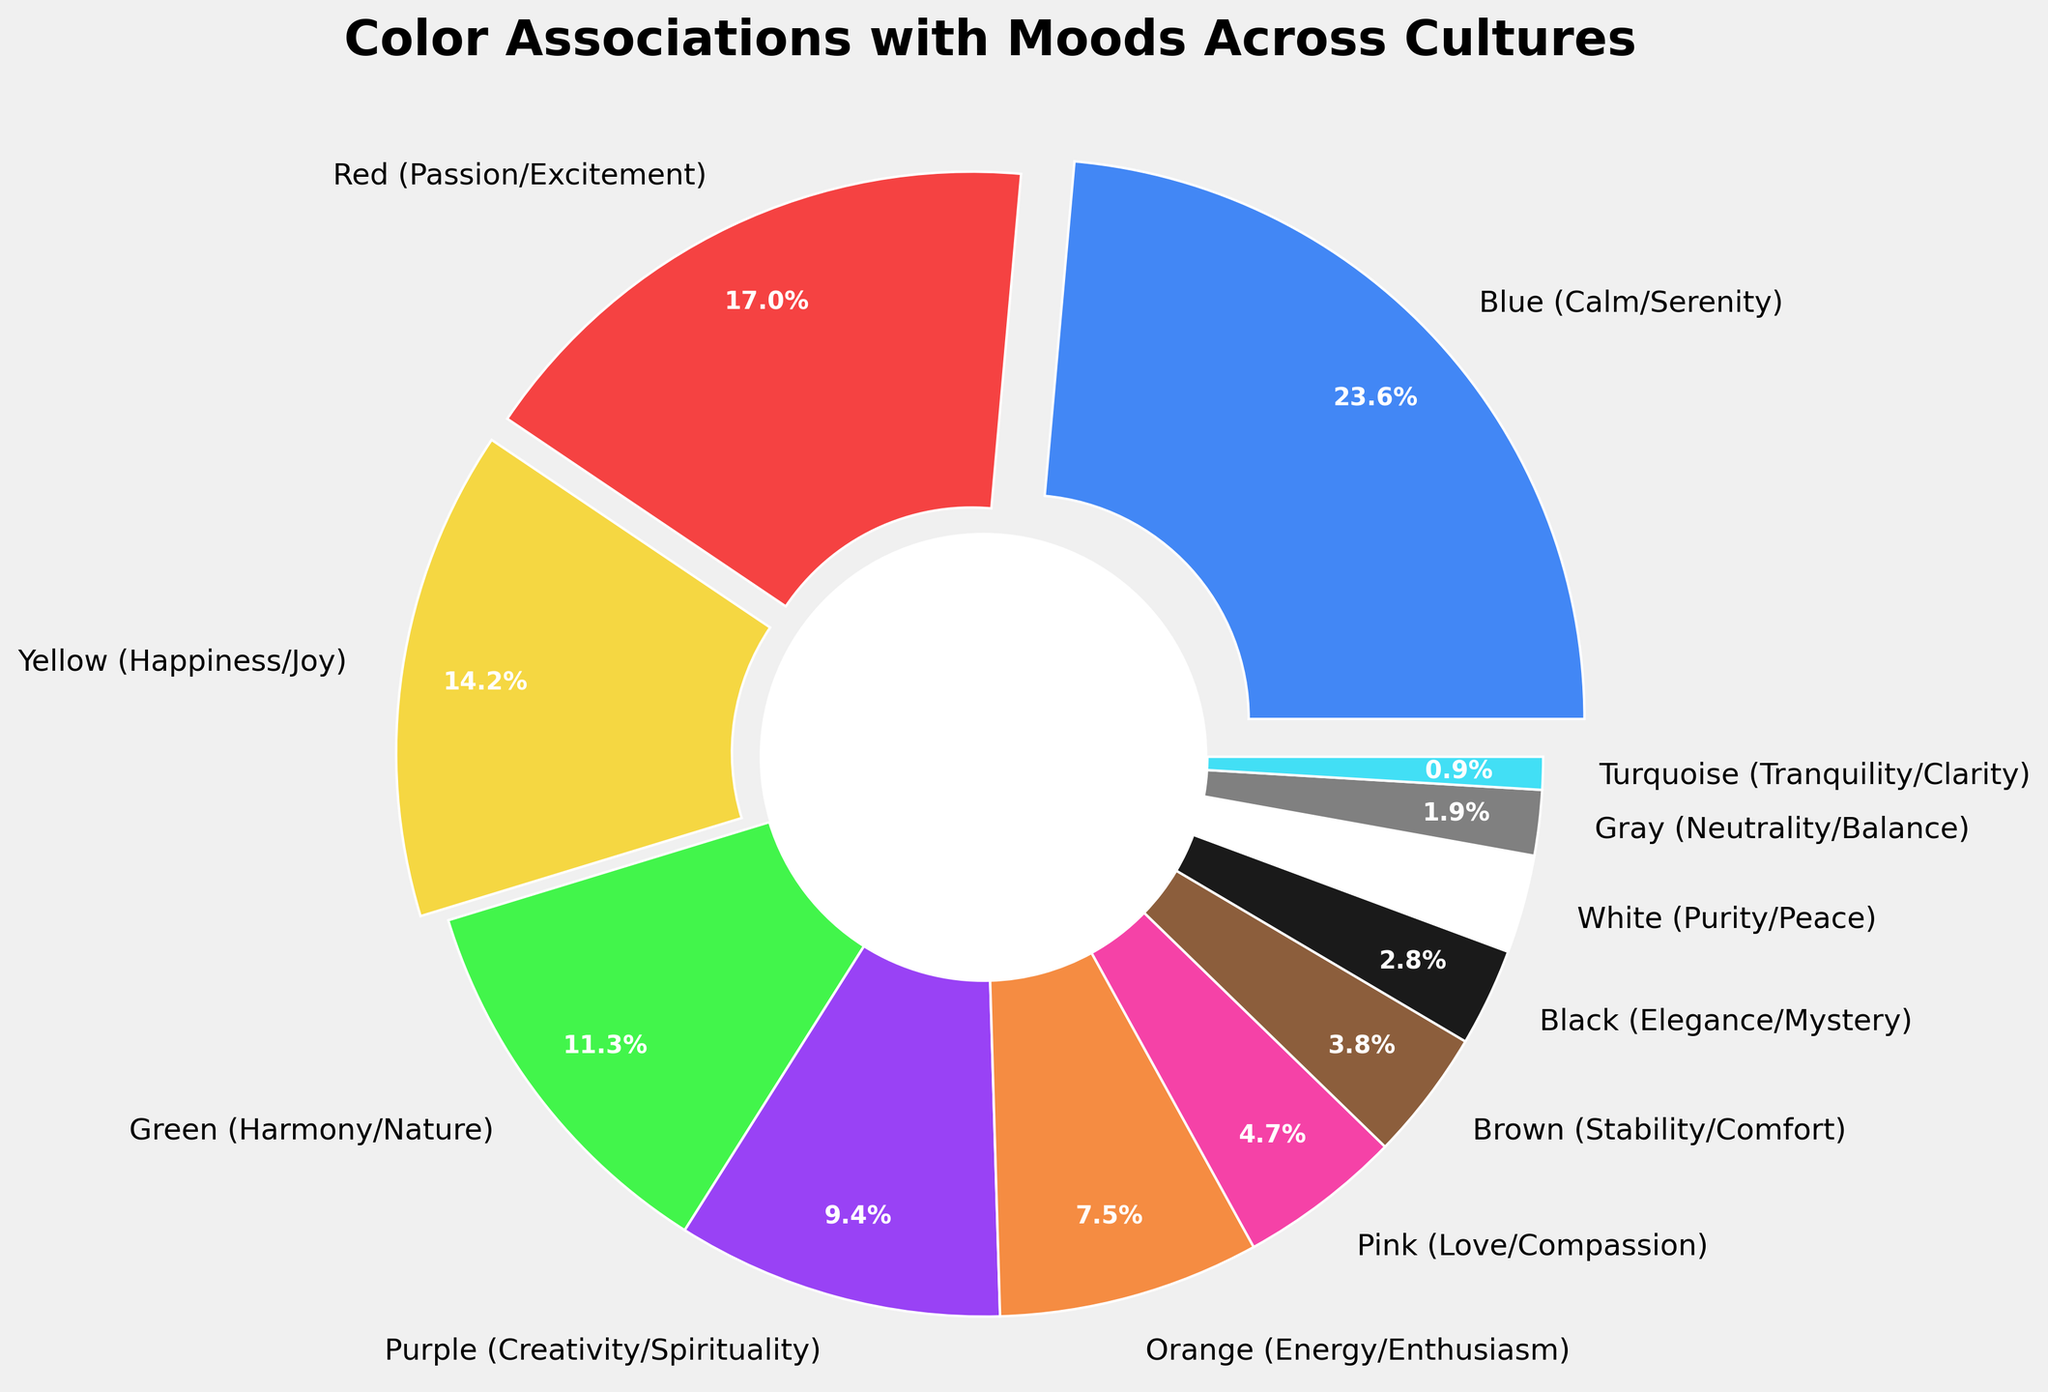Which color is most commonly associated with calm or serenity? By examining the pie chart, the segment with the label "Blue (Calm/Serenity)" is the largest, indicating it has the highest percentage.
Answer: Blue Which mood is least associated with a color according to the pie chart? The smallest segment in the pie chart corresponds to the label "Turquoise (Tranquility/Clarity)", indicating it has the lowest percentage.
Answer: Tranquility/Clarity What is the total percentage of colors associated with positive moods (Calm/Serenity, Happiness/Joy, Energy/Enthusiasm, Love/Compassion)? Adding the percentages of Blue (25), Yellow (15), Orange (8), and Pink (5) gives us 25 + 15 + 8 + 5 = 53%.
Answer: 53% How does the percentage of colors associated with Passion/Excitement compare to those associated with Harmony/Nature? By comparing the segments for Red (18) and Green (12), we can see that the segment for Red is larger, indicating it has a higher percentage.
Answer: Passion/Excitement is more Which two colors combined make up a quarter of the total pie chart? Summing the percentages, we find that Yellow (15%) and Green (12%) together add up to 15 + 12 = 27%, which is slightly over a quarter. Therefore, we look for combinations making 25%: Blue (25%) fits exactly. But for exact pairs: Consider adding other pairs like Red (18%) and adding until close to 25%, but here, this single suits as it met 25%.
Answer: There's no exact match for pairs, but Blue alone covers 25% What percentage of the pie chart is related to creativity and spirituality? The pie chart shows that Purple (Creativity/Spirituality) has a segment labeled with a percentage of 10%.
Answer: 10% Are there more colors associated with calm moods or passionate moods? Adding the calm moods (Blue - 25%, Green - 12%, White - 3%, Gray - 2%, Turquoise - 1%) totals 43%. For passionate moods (Red - 18%, Purple - 10%, Orange - 8%, Pink - 5%), it totals 41%.
Answer: Calm moods are more How does the percentage of Happiness/Joy compare to Stability/Comfort? By comparing the segments of Yellow (15%) and Brown (4%), it is clear that Yellow is larger.
Answer: Happiness/Joy is more What's the difference in percentage between the colors associated with Neutrality/Balance and those associated with Elegance/Mystery? By comparing Gray (2%) and Black (3%), the difference is 3% - 2% = 1%.
Answer: 1% Which color representing Harmony/Nature occupies in the pie chart? Looking directly at the segment labeled "Green (Harmony/Nature)", it occupies a 12% portion of the pie chart.
Answer: Green 